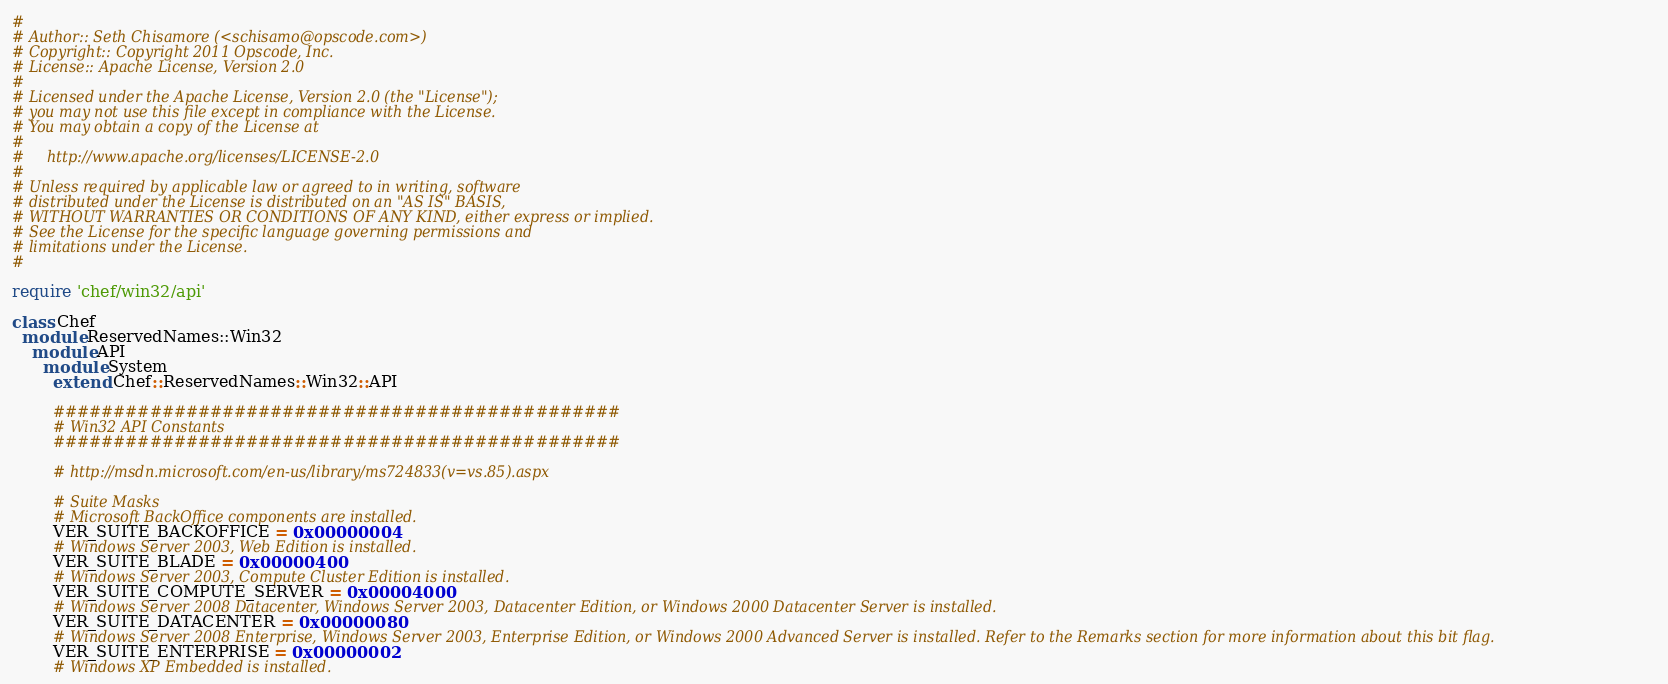Convert code to text. <code><loc_0><loc_0><loc_500><loc_500><_Ruby_>#
# Author:: Seth Chisamore (<schisamo@opscode.com>)
# Copyright:: Copyright 2011 Opscode, Inc.
# License:: Apache License, Version 2.0
#
# Licensed under the Apache License, Version 2.0 (the "License");
# you may not use this file except in compliance with the License.
# You may obtain a copy of the License at
#
#     http://www.apache.org/licenses/LICENSE-2.0
#
# Unless required by applicable law or agreed to in writing, software
# distributed under the License is distributed on an "AS IS" BASIS,
# WITHOUT WARRANTIES OR CONDITIONS OF ANY KIND, either express or implied.
# See the License for the specific language governing permissions and
# limitations under the License.
#

require 'chef/win32/api'

class Chef
  module ReservedNames::Win32
    module API
      module System
        extend Chef::ReservedNames::Win32::API

        ###############################################
        # Win32 API Constants
        ###############################################

        # http://msdn.microsoft.com/en-us/library/ms724833(v=vs.85).aspx

        # Suite Masks
        # Microsoft BackOffice components are installed.
        VER_SUITE_BACKOFFICE = 0x00000004
        # Windows Server 2003, Web Edition is installed.
        VER_SUITE_BLADE = 0x00000400
        # Windows Server 2003, Compute Cluster Edition is installed.
        VER_SUITE_COMPUTE_SERVER = 0x00004000
        # Windows Server 2008 Datacenter, Windows Server 2003, Datacenter Edition, or Windows 2000 Datacenter Server is installed.
        VER_SUITE_DATACENTER = 0x00000080
        # Windows Server 2008 Enterprise, Windows Server 2003, Enterprise Edition, or Windows 2000 Advanced Server is installed. Refer to the Remarks section for more information about this bit flag.
        VER_SUITE_ENTERPRISE = 0x00000002
        # Windows XP Embedded is installed.</code> 